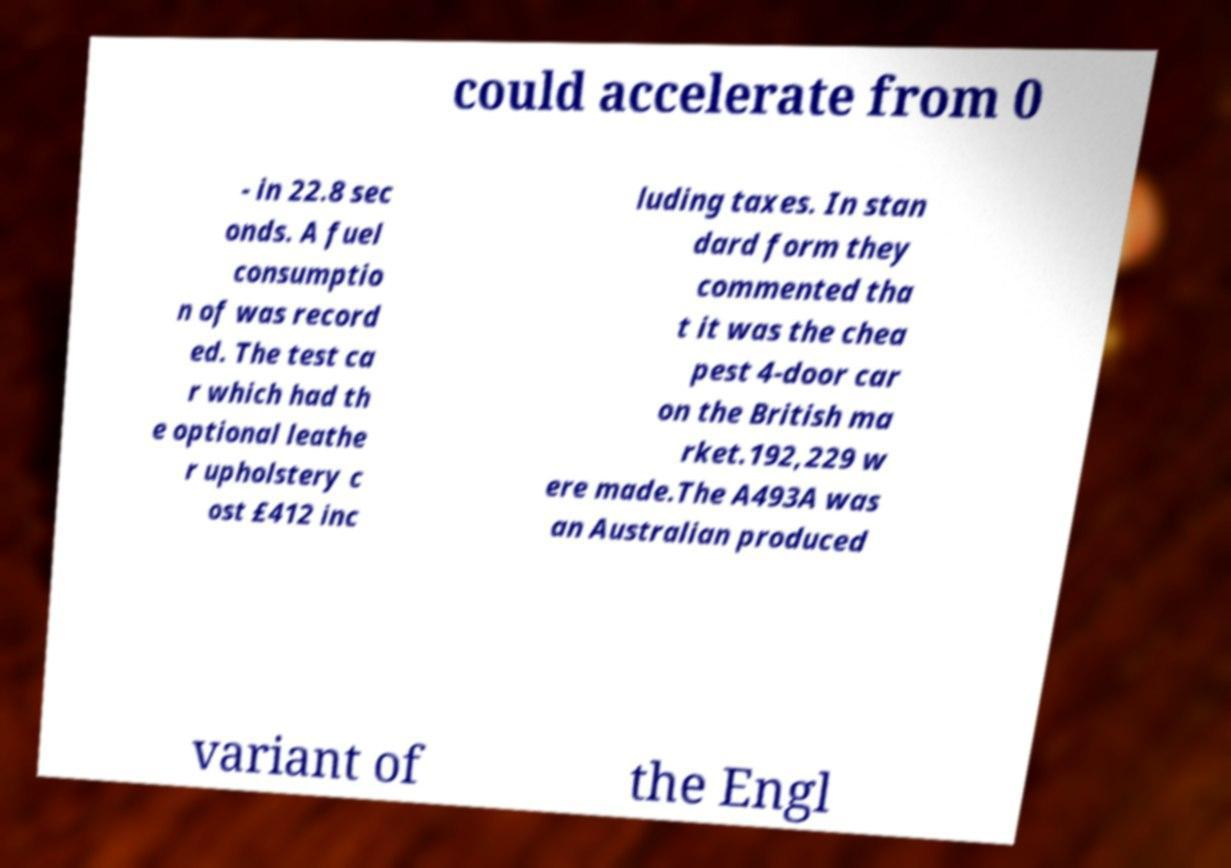Can you read and provide the text displayed in the image?This photo seems to have some interesting text. Can you extract and type it out for me? could accelerate from 0 - in 22.8 sec onds. A fuel consumptio n of was record ed. The test ca r which had th e optional leathe r upholstery c ost £412 inc luding taxes. In stan dard form they commented tha t it was the chea pest 4-door car on the British ma rket.192,229 w ere made.The A493A was an Australian produced variant of the Engl 